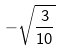<formula> <loc_0><loc_0><loc_500><loc_500>- \sqrt { \frac { 3 } { 1 0 } }</formula> 